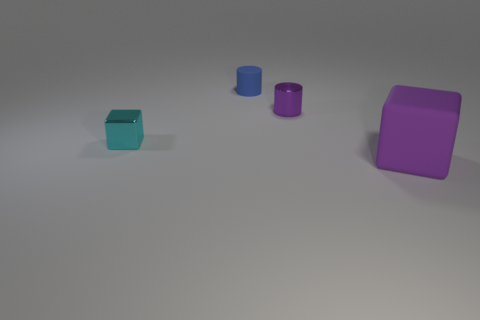What number of other objects are the same color as the tiny matte cylinder?
Ensure brevity in your answer.  0. There is a rubber thing that is behind the metal object that is left of the metallic cylinder; what size is it?
Your answer should be very brief. Small. Is the material of the purple thing behind the large rubber cube the same as the big thing?
Your answer should be very brief. No. What is the shape of the object behind the tiny metal cylinder?
Keep it short and to the point. Cylinder. How many metallic things have the same size as the purple cylinder?
Ensure brevity in your answer.  1. The purple rubber thing is what size?
Your answer should be very brief. Large. There is a rubber block; what number of purple objects are to the left of it?
Ensure brevity in your answer.  1. The tiny thing that is made of the same material as the large purple object is what shape?
Your answer should be compact. Cylinder. Are there fewer purple matte cubes that are right of the large cube than tiny metal cylinders that are right of the small cube?
Provide a succinct answer. Yes. Are there more tiny blue rubber cylinders than tiny green rubber spheres?
Your answer should be compact. Yes. 